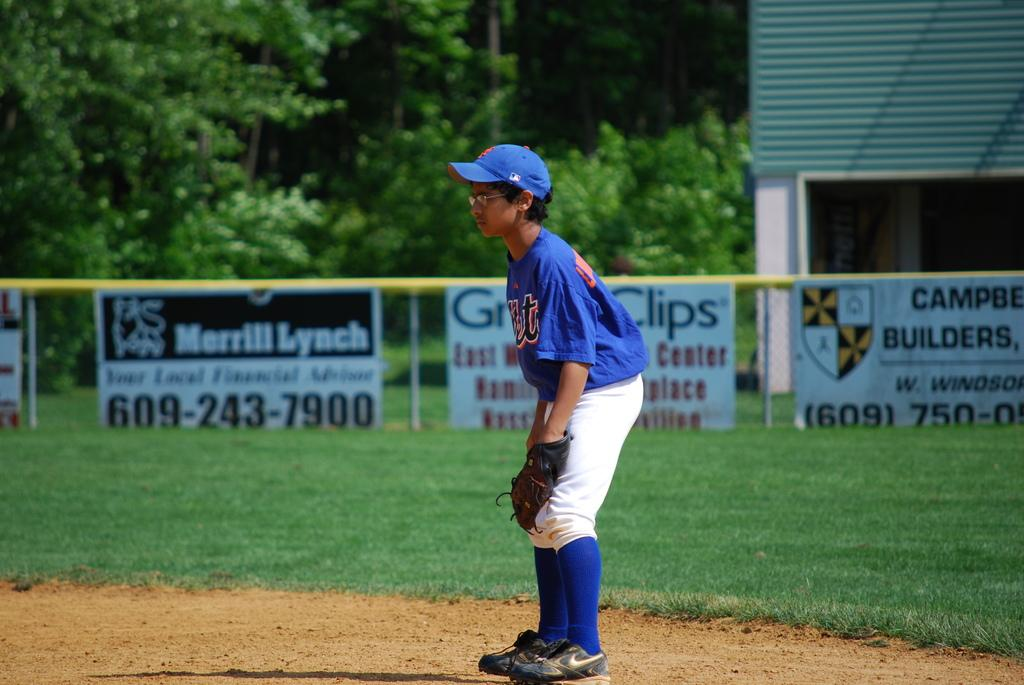<image>
Summarize the visual content of the image. A baseball player in blue and white with the logo for merrill lynch in the background. 